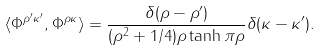<formula> <loc_0><loc_0><loc_500><loc_500>\langle \Phi ^ { \rho ^ { \prime } \kappa ^ { \prime } } , \Phi ^ { \rho \kappa } \rangle = \frac { \delta ( \rho - \rho ^ { \prime } ) } { ( \rho ^ { 2 } + 1 / 4 ) \rho \tanh \pi \rho } \delta ( \kappa - \kappa ^ { \prime } ) .</formula> 